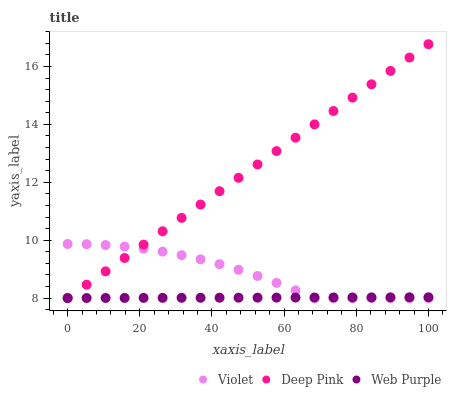Does Web Purple have the minimum area under the curve?
Answer yes or no. Yes. Does Deep Pink have the maximum area under the curve?
Answer yes or no. Yes. Does Violet have the minimum area under the curve?
Answer yes or no. No. Does Violet have the maximum area under the curve?
Answer yes or no. No. Is Web Purple the smoothest?
Answer yes or no. Yes. Is Violet the roughest?
Answer yes or no. Yes. Is Deep Pink the smoothest?
Answer yes or no. No. Is Deep Pink the roughest?
Answer yes or no. No. Does Web Purple have the lowest value?
Answer yes or no. Yes. Does Deep Pink have the highest value?
Answer yes or no. Yes. Does Violet have the highest value?
Answer yes or no. No. Does Web Purple intersect Violet?
Answer yes or no. Yes. Is Web Purple less than Violet?
Answer yes or no. No. Is Web Purple greater than Violet?
Answer yes or no. No. 